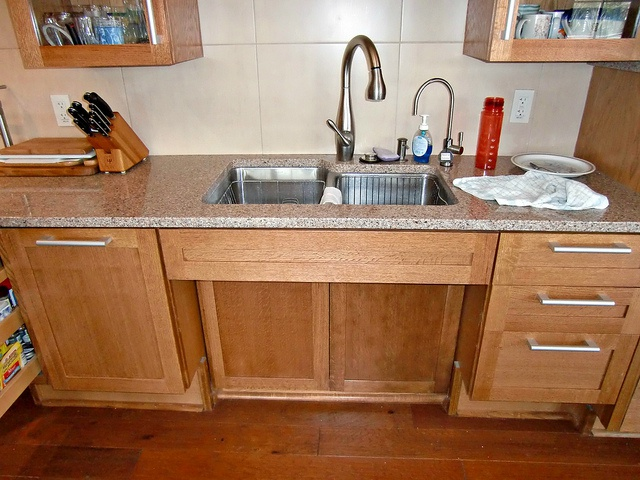Describe the objects in this image and their specific colors. I can see sink in gray, lightgray, darkgray, and black tones, sink in gray, darkgray, black, and lightgray tones, bottle in gray, brown, and maroon tones, cup in gray, darkgray, and lightgray tones, and cup in gray, darkgray, and lightgray tones in this image. 